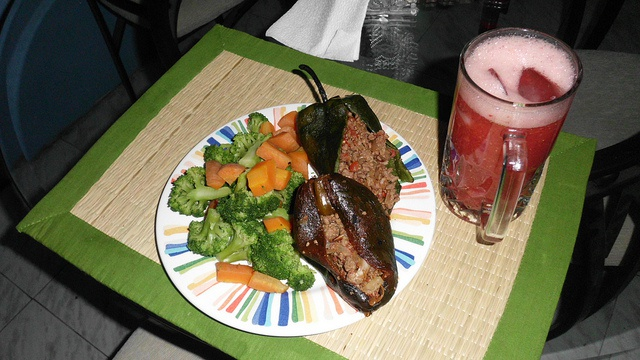Describe the objects in this image and their specific colors. I can see dining table in black, darkgreen, white, and tan tones, cup in black, lightpink, maroon, and brown tones, broccoli in black, darkgreen, and olive tones, carrot in black, red, and orange tones, and carrot in black, orange, and red tones in this image. 